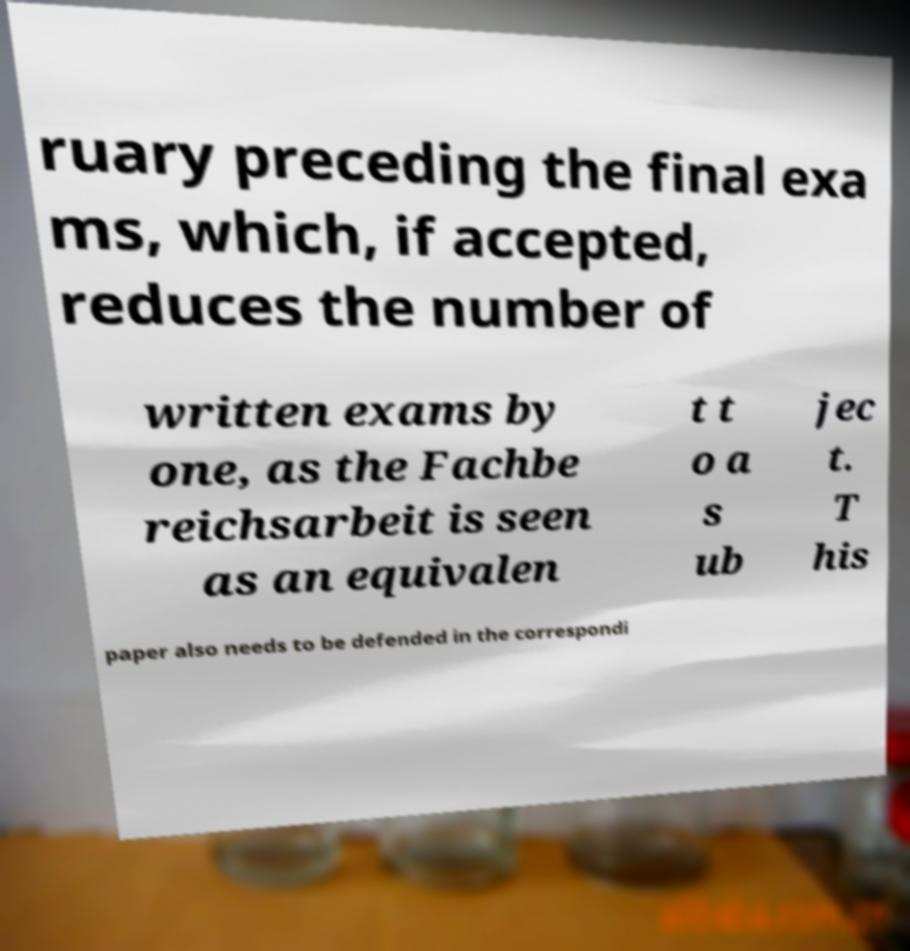There's text embedded in this image that I need extracted. Can you transcribe it verbatim? ruary preceding the final exa ms, which, if accepted, reduces the number of written exams by one, as the Fachbe reichsarbeit is seen as an equivalen t t o a s ub jec t. T his paper also needs to be defended in the correspondi 